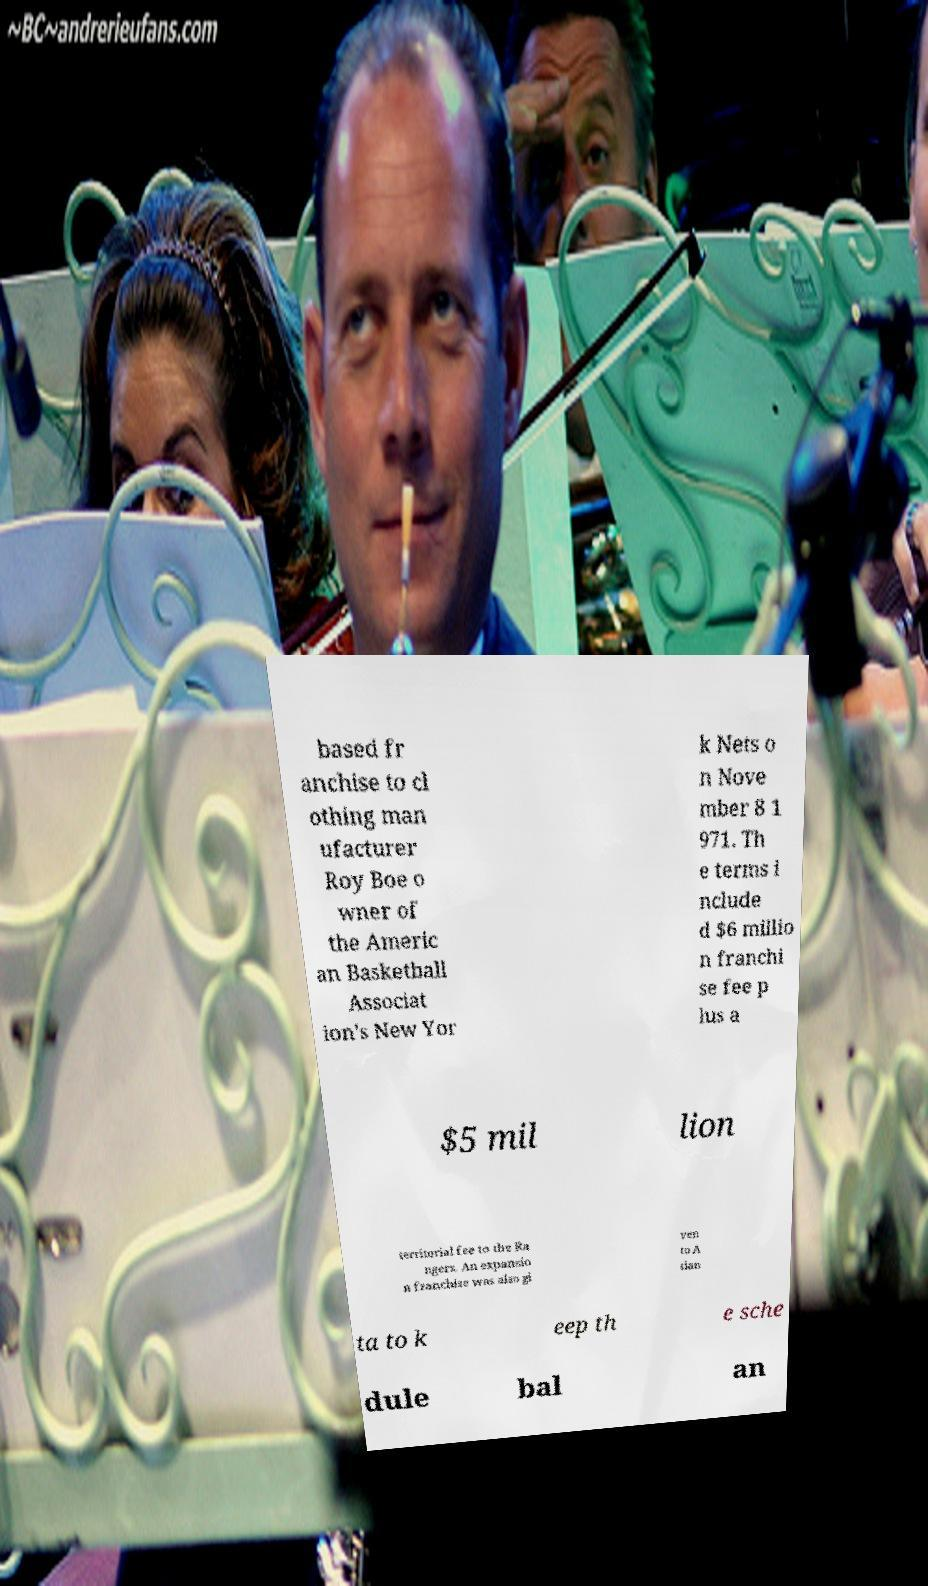Please identify and transcribe the text found in this image. based fr anchise to cl othing man ufacturer Roy Boe o wner of the Americ an Basketball Associat ion's New Yor k Nets o n Nove mber 8 1 971. Th e terms i nclude d $6 millio n franchi se fee p lus a $5 mil lion territorial fee to the Ra ngers. An expansio n franchise was also gi ven to A tlan ta to k eep th e sche dule bal an 